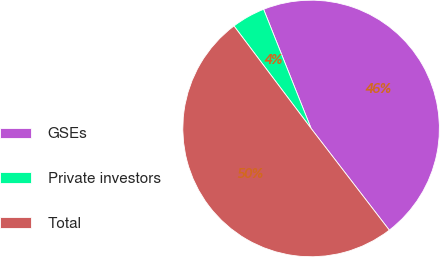Convert chart to OTSL. <chart><loc_0><loc_0><loc_500><loc_500><pie_chart><fcel>GSEs<fcel>Private investors<fcel>Total<nl><fcel>45.6%<fcel>4.23%<fcel>50.16%<nl></chart> 